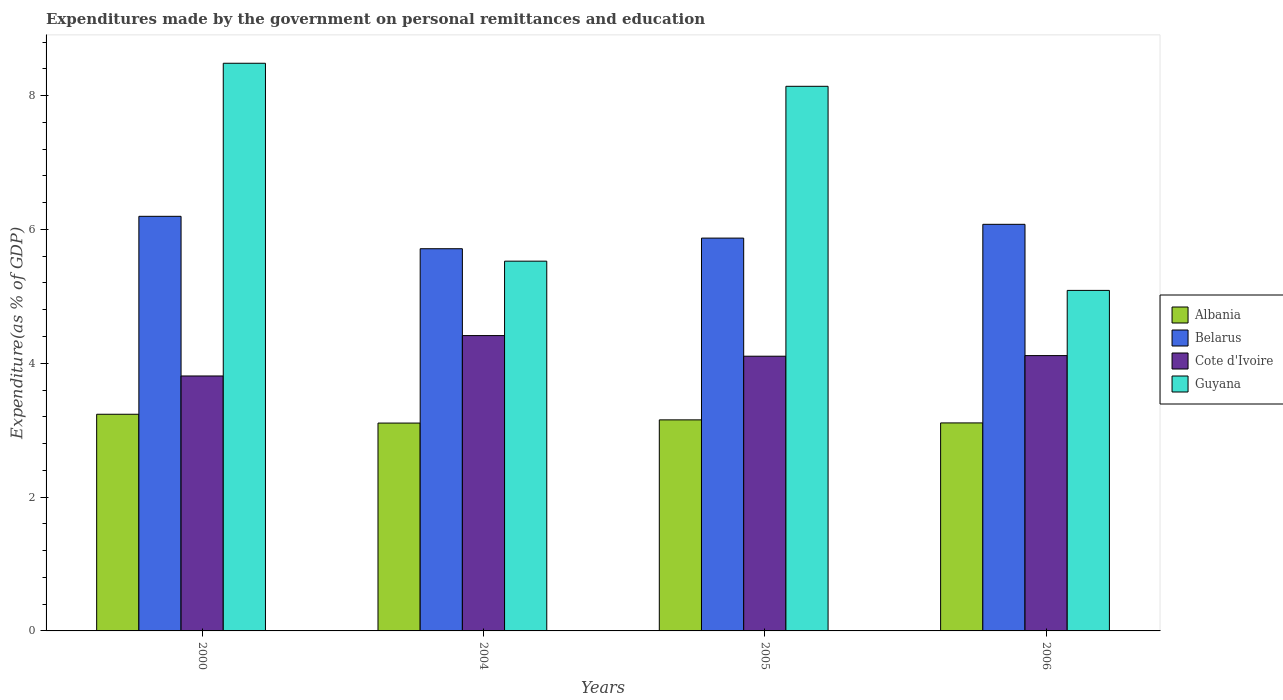How many different coloured bars are there?
Ensure brevity in your answer.  4. How many bars are there on the 3rd tick from the right?
Make the answer very short. 4. What is the label of the 2nd group of bars from the left?
Ensure brevity in your answer.  2004. What is the expenditures made by the government on personal remittances and education in Belarus in 2006?
Give a very brief answer. 6.08. Across all years, what is the maximum expenditures made by the government on personal remittances and education in Cote d'Ivoire?
Offer a very short reply. 4.41. Across all years, what is the minimum expenditures made by the government on personal remittances and education in Belarus?
Make the answer very short. 5.71. In which year was the expenditures made by the government on personal remittances and education in Guyana maximum?
Your answer should be very brief. 2000. What is the total expenditures made by the government on personal remittances and education in Belarus in the graph?
Your answer should be compact. 23.86. What is the difference between the expenditures made by the government on personal remittances and education in Cote d'Ivoire in 2000 and that in 2005?
Ensure brevity in your answer.  -0.3. What is the difference between the expenditures made by the government on personal remittances and education in Guyana in 2000 and the expenditures made by the government on personal remittances and education in Belarus in 2005?
Ensure brevity in your answer.  2.61. What is the average expenditures made by the government on personal remittances and education in Guyana per year?
Offer a terse response. 6.81. In the year 2004, what is the difference between the expenditures made by the government on personal remittances and education in Albania and expenditures made by the government on personal remittances and education in Cote d'Ivoire?
Offer a very short reply. -1.31. What is the ratio of the expenditures made by the government on personal remittances and education in Guyana in 2000 to that in 2005?
Give a very brief answer. 1.04. Is the difference between the expenditures made by the government on personal remittances and education in Albania in 2000 and 2006 greater than the difference between the expenditures made by the government on personal remittances and education in Cote d'Ivoire in 2000 and 2006?
Your answer should be compact. Yes. What is the difference between the highest and the second highest expenditures made by the government on personal remittances and education in Belarus?
Give a very brief answer. 0.12. What is the difference between the highest and the lowest expenditures made by the government on personal remittances and education in Albania?
Your answer should be very brief. 0.13. In how many years, is the expenditures made by the government on personal remittances and education in Belarus greater than the average expenditures made by the government on personal remittances and education in Belarus taken over all years?
Give a very brief answer. 2. Is the sum of the expenditures made by the government on personal remittances and education in Cote d'Ivoire in 2004 and 2006 greater than the maximum expenditures made by the government on personal remittances and education in Albania across all years?
Offer a very short reply. Yes. What does the 2nd bar from the left in 2006 represents?
Offer a terse response. Belarus. What does the 2nd bar from the right in 2006 represents?
Make the answer very short. Cote d'Ivoire. Are all the bars in the graph horizontal?
Make the answer very short. No. What is the difference between two consecutive major ticks on the Y-axis?
Ensure brevity in your answer.  2. Are the values on the major ticks of Y-axis written in scientific E-notation?
Provide a succinct answer. No. Does the graph contain grids?
Keep it short and to the point. No. How many legend labels are there?
Make the answer very short. 4. How are the legend labels stacked?
Provide a short and direct response. Vertical. What is the title of the graph?
Offer a terse response. Expenditures made by the government on personal remittances and education. What is the label or title of the Y-axis?
Offer a terse response. Expenditure(as % of GDP). What is the Expenditure(as % of GDP) of Albania in 2000?
Your answer should be compact. 3.24. What is the Expenditure(as % of GDP) of Belarus in 2000?
Offer a terse response. 6.2. What is the Expenditure(as % of GDP) of Cote d'Ivoire in 2000?
Ensure brevity in your answer.  3.81. What is the Expenditure(as % of GDP) of Guyana in 2000?
Offer a very short reply. 8.48. What is the Expenditure(as % of GDP) of Albania in 2004?
Your answer should be very brief. 3.11. What is the Expenditure(as % of GDP) of Belarus in 2004?
Ensure brevity in your answer.  5.71. What is the Expenditure(as % of GDP) in Cote d'Ivoire in 2004?
Provide a succinct answer. 4.41. What is the Expenditure(as % of GDP) of Guyana in 2004?
Your answer should be very brief. 5.53. What is the Expenditure(as % of GDP) of Albania in 2005?
Your response must be concise. 3.15. What is the Expenditure(as % of GDP) in Belarus in 2005?
Your answer should be compact. 5.87. What is the Expenditure(as % of GDP) in Cote d'Ivoire in 2005?
Provide a succinct answer. 4.11. What is the Expenditure(as % of GDP) in Guyana in 2005?
Your response must be concise. 8.14. What is the Expenditure(as % of GDP) in Albania in 2006?
Provide a short and direct response. 3.11. What is the Expenditure(as % of GDP) in Belarus in 2006?
Offer a terse response. 6.08. What is the Expenditure(as % of GDP) of Cote d'Ivoire in 2006?
Your answer should be compact. 4.11. What is the Expenditure(as % of GDP) of Guyana in 2006?
Make the answer very short. 5.09. Across all years, what is the maximum Expenditure(as % of GDP) of Albania?
Give a very brief answer. 3.24. Across all years, what is the maximum Expenditure(as % of GDP) in Belarus?
Make the answer very short. 6.2. Across all years, what is the maximum Expenditure(as % of GDP) in Cote d'Ivoire?
Offer a terse response. 4.41. Across all years, what is the maximum Expenditure(as % of GDP) of Guyana?
Offer a terse response. 8.48. Across all years, what is the minimum Expenditure(as % of GDP) in Albania?
Make the answer very short. 3.11. Across all years, what is the minimum Expenditure(as % of GDP) of Belarus?
Provide a succinct answer. 5.71. Across all years, what is the minimum Expenditure(as % of GDP) in Cote d'Ivoire?
Your answer should be compact. 3.81. Across all years, what is the minimum Expenditure(as % of GDP) in Guyana?
Keep it short and to the point. 5.09. What is the total Expenditure(as % of GDP) in Albania in the graph?
Offer a very short reply. 12.61. What is the total Expenditure(as % of GDP) in Belarus in the graph?
Provide a succinct answer. 23.86. What is the total Expenditure(as % of GDP) of Cote d'Ivoire in the graph?
Your response must be concise. 16.44. What is the total Expenditure(as % of GDP) of Guyana in the graph?
Your answer should be compact. 27.24. What is the difference between the Expenditure(as % of GDP) of Albania in 2000 and that in 2004?
Offer a very short reply. 0.13. What is the difference between the Expenditure(as % of GDP) of Belarus in 2000 and that in 2004?
Make the answer very short. 0.48. What is the difference between the Expenditure(as % of GDP) of Cote d'Ivoire in 2000 and that in 2004?
Provide a succinct answer. -0.6. What is the difference between the Expenditure(as % of GDP) in Guyana in 2000 and that in 2004?
Offer a very short reply. 2.96. What is the difference between the Expenditure(as % of GDP) of Albania in 2000 and that in 2005?
Your answer should be compact. 0.08. What is the difference between the Expenditure(as % of GDP) of Belarus in 2000 and that in 2005?
Ensure brevity in your answer.  0.33. What is the difference between the Expenditure(as % of GDP) in Cote d'Ivoire in 2000 and that in 2005?
Provide a succinct answer. -0.3. What is the difference between the Expenditure(as % of GDP) in Guyana in 2000 and that in 2005?
Your answer should be very brief. 0.34. What is the difference between the Expenditure(as % of GDP) of Albania in 2000 and that in 2006?
Make the answer very short. 0.13. What is the difference between the Expenditure(as % of GDP) in Belarus in 2000 and that in 2006?
Keep it short and to the point. 0.12. What is the difference between the Expenditure(as % of GDP) in Cote d'Ivoire in 2000 and that in 2006?
Provide a short and direct response. -0.3. What is the difference between the Expenditure(as % of GDP) of Guyana in 2000 and that in 2006?
Keep it short and to the point. 3.39. What is the difference between the Expenditure(as % of GDP) in Albania in 2004 and that in 2005?
Keep it short and to the point. -0.05. What is the difference between the Expenditure(as % of GDP) in Belarus in 2004 and that in 2005?
Provide a short and direct response. -0.16. What is the difference between the Expenditure(as % of GDP) of Cote d'Ivoire in 2004 and that in 2005?
Offer a terse response. 0.31. What is the difference between the Expenditure(as % of GDP) in Guyana in 2004 and that in 2005?
Make the answer very short. -2.61. What is the difference between the Expenditure(as % of GDP) of Albania in 2004 and that in 2006?
Make the answer very short. -0. What is the difference between the Expenditure(as % of GDP) of Belarus in 2004 and that in 2006?
Provide a succinct answer. -0.36. What is the difference between the Expenditure(as % of GDP) of Cote d'Ivoire in 2004 and that in 2006?
Offer a terse response. 0.3. What is the difference between the Expenditure(as % of GDP) in Guyana in 2004 and that in 2006?
Give a very brief answer. 0.44. What is the difference between the Expenditure(as % of GDP) in Albania in 2005 and that in 2006?
Provide a succinct answer. 0.05. What is the difference between the Expenditure(as % of GDP) of Belarus in 2005 and that in 2006?
Your answer should be very brief. -0.21. What is the difference between the Expenditure(as % of GDP) of Cote d'Ivoire in 2005 and that in 2006?
Your answer should be compact. -0.01. What is the difference between the Expenditure(as % of GDP) of Guyana in 2005 and that in 2006?
Give a very brief answer. 3.05. What is the difference between the Expenditure(as % of GDP) of Albania in 2000 and the Expenditure(as % of GDP) of Belarus in 2004?
Ensure brevity in your answer.  -2.47. What is the difference between the Expenditure(as % of GDP) of Albania in 2000 and the Expenditure(as % of GDP) of Cote d'Ivoire in 2004?
Ensure brevity in your answer.  -1.18. What is the difference between the Expenditure(as % of GDP) of Albania in 2000 and the Expenditure(as % of GDP) of Guyana in 2004?
Offer a terse response. -2.29. What is the difference between the Expenditure(as % of GDP) in Belarus in 2000 and the Expenditure(as % of GDP) in Cote d'Ivoire in 2004?
Your answer should be compact. 1.78. What is the difference between the Expenditure(as % of GDP) in Belarus in 2000 and the Expenditure(as % of GDP) in Guyana in 2004?
Your answer should be compact. 0.67. What is the difference between the Expenditure(as % of GDP) in Cote d'Ivoire in 2000 and the Expenditure(as % of GDP) in Guyana in 2004?
Provide a succinct answer. -1.72. What is the difference between the Expenditure(as % of GDP) in Albania in 2000 and the Expenditure(as % of GDP) in Belarus in 2005?
Provide a succinct answer. -2.63. What is the difference between the Expenditure(as % of GDP) of Albania in 2000 and the Expenditure(as % of GDP) of Cote d'Ivoire in 2005?
Ensure brevity in your answer.  -0.87. What is the difference between the Expenditure(as % of GDP) in Albania in 2000 and the Expenditure(as % of GDP) in Guyana in 2005?
Offer a very short reply. -4.9. What is the difference between the Expenditure(as % of GDP) of Belarus in 2000 and the Expenditure(as % of GDP) of Cote d'Ivoire in 2005?
Your response must be concise. 2.09. What is the difference between the Expenditure(as % of GDP) of Belarus in 2000 and the Expenditure(as % of GDP) of Guyana in 2005?
Make the answer very short. -1.94. What is the difference between the Expenditure(as % of GDP) in Cote d'Ivoire in 2000 and the Expenditure(as % of GDP) in Guyana in 2005?
Offer a terse response. -4.33. What is the difference between the Expenditure(as % of GDP) of Albania in 2000 and the Expenditure(as % of GDP) of Belarus in 2006?
Your answer should be compact. -2.84. What is the difference between the Expenditure(as % of GDP) of Albania in 2000 and the Expenditure(as % of GDP) of Cote d'Ivoire in 2006?
Provide a succinct answer. -0.88. What is the difference between the Expenditure(as % of GDP) in Albania in 2000 and the Expenditure(as % of GDP) in Guyana in 2006?
Your answer should be compact. -1.85. What is the difference between the Expenditure(as % of GDP) in Belarus in 2000 and the Expenditure(as % of GDP) in Cote d'Ivoire in 2006?
Your response must be concise. 2.08. What is the difference between the Expenditure(as % of GDP) in Belarus in 2000 and the Expenditure(as % of GDP) in Guyana in 2006?
Provide a succinct answer. 1.11. What is the difference between the Expenditure(as % of GDP) in Cote d'Ivoire in 2000 and the Expenditure(as % of GDP) in Guyana in 2006?
Make the answer very short. -1.28. What is the difference between the Expenditure(as % of GDP) in Albania in 2004 and the Expenditure(as % of GDP) in Belarus in 2005?
Give a very brief answer. -2.76. What is the difference between the Expenditure(as % of GDP) in Albania in 2004 and the Expenditure(as % of GDP) in Cote d'Ivoire in 2005?
Offer a terse response. -1. What is the difference between the Expenditure(as % of GDP) in Albania in 2004 and the Expenditure(as % of GDP) in Guyana in 2005?
Keep it short and to the point. -5.03. What is the difference between the Expenditure(as % of GDP) in Belarus in 2004 and the Expenditure(as % of GDP) in Cote d'Ivoire in 2005?
Make the answer very short. 1.61. What is the difference between the Expenditure(as % of GDP) of Belarus in 2004 and the Expenditure(as % of GDP) of Guyana in 2005?
Provide a short and direct response. -2.43. What is the difference between the Expenditure(as % of GDP) of Cote d'Ivoire in 2004 and the Expenditure(as % of GDP) of Guyana in 2005?
Your answer should be compact. -3.73. What is the difference between the Expenditure(as % of GDP) of Albania in 2004 and the Expenditure(as % of GDP) of Belarus in 2006?
Offer a very short reply. -2.97. What is the difference between the Expenditure(as % of GDP) in Albania in 2004 and the Expenditure(as % of GDP) in Cote d'Ivoire in 2006?
Make the answer very short. -1.01. What is the difference between the Expenditure(as % of GDP) of Albania in 2004 and the Expenditure(as % of GDP) of Guyana in 2006?
Keep it short and to the point. -1.98. What is the difference between the Expenditure(as % of GDP) in Belarus in 2004 and the Expenditure(as % of GDP) in Cote d'Ivoire in 2006?
Your answer should be compact. 1.6. What is the difference between the Expenditure(as % of GDP) in Belarus in 2004 and the Expenditure(as % of GDP) in Guyana in 2006?
Provide a short and direct response. 0.62. What is the difference between the Expenditure(as % of GDP) in Cote d'Ivoire in 2004 and the Expenditure(as % of GDP) in Guyana in 2006?
Ensure brevity in your answer.  -0.68. What is the difference between the Expenditure(as % of GDP) in Albania in 2005 and the Expenditure(as % of GDP) in Belarus in 2006?
Make the answer very short. -2.92. What is the difference between the Expenditure(as % of GDP) of Albania in 2005 and the Expenditure(as % of GDP) of Cote d'Ivoire in 2006?
Offer a very short reply. -0.96. What is the difference between the Expenditure(as % of GDP) of Albania in 2005 and the Expenditure(as % of GDP) of Guyana in 2006?
Provide a short and direct response. -1.93. What is the difference between the Expenditure(as % of GDP) in Belarus in 2005 and the Expenditure(as % of GDP) in Cote d'Ivoire in 2006?
Your answer should be compact. 1.76. What is the difference between the Expenditure(as % of GDP) in Belarus in 2005 and the Expenditure(as % of GDP) in Guyana in 2006?
Keep it short and to the point. 0.78. What is the difference between the Expenditure(as % of GDP) of Cote d'Ivoire in 2005 and the Expenditure(as % of GDP) of Guyana in 2006?
Make the answer very short. -0.98. What is the average Expenditure(as % of GDP) of Albania per year?
Your answer should be very brief. 3.15. What is the average Expenditure(as % of GDP) in Belarus per year?
Offer a terse response. 5.96. What is the average Expenditure(as % of GDP) of Cote d'Ivoire per year?
Provide a short and direct response. 4.11. What is the average Expenditure(as % of GDP) in Guyana per year?
Make the answer very short. 6.81. In the year 2000, what is the difference between the Expenditure(as % of GDP) in Albania and Expenditure(as % of GDP) in Belarus?
Your response must be concise. -2.96. In the year 2000, what is the difference between the Expenditure(as % of GDP) of Albania and Expenditure(as % of GDP) of Cote d'Ivoire?
Give a very brief answer. -0.57. In the year 2000, what is the difference between the Expenditure(as % of GDP) of Albania and Expenditure(as % of GDP) of Guyana?
Keep it short and to the point. -5.25. In the year 2000, what is the difference between the Expenditure(as % of GDP) in Belarus and Expenditure(as % of GDP) in Cote d'Ivoire?
Keep it short and to the point. 2.39. In the year 2000, what is the difference between the Expenditure(as % of GDP) in Belarus and Expenditure(as % of GDP) in Guyana?
Ensure brevity in your answer.  -2.29. In the year 2000, what is the difference between the Expenditure(as % of GDP) in Cote d'Ivoire and Expenditure(as % of GDP) in Guyana?
Keep it short and to the point. -4.67. In the year 2004, what is the difference between the Expenditure(as % of GDP) in Albania and Expenditure(as % of GDP) in Belarus?
Ensure brevity in your answer.  -2.61. In the year 2004, what is the difference between the Expenditure(as % of GDP) of Albania and Expenditure(as % of GDP) of Cote d'Ivoire?
Offer a very short reply. -1.31. In the year 2004, what is the difference between the Expenditure(as % of GDP) of Albania and Expenditure(as % of GDP) of Guyana?
Your answer should be very brief. -2.42. In the year 2004, what is the difference between the Expenditure(as % of GDP) of Belarus and Expenditure(as % of GDP) of Cote d'Ivoire?
Offer a terse response. 1.3. In the year 2004, what is the difference between the Expenditure(as % of GDP) of Belarus and Expenditure(as % of GDP) of Guyana?
Ensure brevity in your answer.  0.19. In the year 2004, what is the difference between the Expenditure(as % of GDP) of Cote d'Ivoire and Expenditure(as % of GDP) of Guyana?
Make the answer very short. -1.11. In the year 2005, what is the difference between the Expenditure(as % of GDP) in Albania and Expenditure(as % of GDP) in Belarus?
Offer a terse response. -2.72. In the year 2005, what is the difference between the Expenditure(as % of GDP) of Albania and Expenditure(as % of GDP) of Cote d'Ivoire?
Your answer should be very brief. -0.95. In the year 2005, what is the difference between the Expenditure(as % of GDP) of Albania and Expenditure(as % of GDP) of Guyana?
Provide a short and direct response. -4.99. In the year 2005, what is the difference between the Expenditure(as % of GDP) of Belarus and Expenditure(as % of GDP) of Cote d'Ivoire?
Offer a very short reply. 1.77. In the year 2005, what is the difference between the Expenditure(as % of GDP) of Belarus and Expenditure(as % of GDP) of Guyana?
Your answer should be very brief. -2.27. In the year 2005, what is the difference between the Expenditure(as % of GDP) in Cote d'Ivoire and Expenditure(as % of GDP) in Guyana?
Your answer should be very brief. -4.03. In the year 2006, what is the difference between the Expenditure(as % of GDP) of Albania and Expenditure(as % of GDP) of Belarus?
Your response must be concise. -2.97. In the year 2006, what is the difference between the Expenditure(as % of GDP) of Albania and Expenditure(as % of GDP) of Cote d'Ivoire?
Your response must be concise. -1.01. In the year 2006, what is the difference between the Expenditure(as % of GDP) in Albania and Expenditure(as % of GDP) in Guyana?
Keep it short and to the point. -1.98. In the year 2006, what is the difference between the Expenditure(as % of GDP) of Belarus and Expenditure(as % of GDP) of Cote d'Ivoire?
Keep it short and to the point. 1.96. In the year 2006, what is the difference between the Expenditure(as % of GDP) of Cote d'Ivoire and Expenditure(as % of GDP) of Guyana?
Make the answer very short. -0.97. What is the ratio of the Expenditure(as % of GDP) of Albania in 2000 to that in 2004?
Offer a very short reply. 1.04. What is the ratio of the Expenditure(as % of GDP) in Belarus in 2000 to that in 2004?
Keep it short and to the point. 1.08. What is the ratio of the Expenditure(as % of GDP) of Cote d'Ivoire in 2000 to that in 2004?
Keep it short and to the point. 0.86. What is the ratio of the Expenditure(as % of GDP) in Guyana in 2000 to that in 2004?
Make the answer very short. 1.54. What is the ratio of the Expenditure(as % of GDP) in Albania in 2000 to that in 2005?
Your answer should be compact. 1.03. What is the ratio of the Expenditure(as % of GDP) in Belarus in 2000 to that in 2005?
Your response must be concise. 1.06. What is the ratio of the Expenditure(as % of GDP) of Cote d'Ivoire in 2000 to that in 2005?
Keep it short and to the point. 0.93. What is the ratio of the Expenditure(as % of GDP) of Guyana in 2000 to that in 2005?
Offer a very short reply. 1.04. What is the ratio of the Expenditure(as % of GDP) of Albania in 2000 to that in 2006?
Give a very brief answer. 1.04. What is the ratio of the Expenditure(as % of GDP) of Belarus in 2000 to that in 2006?
Ensure brevity in your answer.  1.02. What is the ratio of the Expenditure(as % of GDP) in Cote d'Ivoire in 2000 to that in 2006?
Offer a very short reply. 0.93. What is the ratio of the Expenditure(as % of GDP) in Guyana in 2000 to that in 2006?
Make the answer very short. 1.67. What is the ratio of the Expenditure(as % of GDP) of Cote d'Ivoire in 2004 to that in 2005?
Offer a terse response. 1.08. What is the ratio of the Expenditure(as % of GDP) of Guyana in 2004 to that in 2005?
Your answer should be very brief. 0.68. What is the ratio of the Expenditure(as % of GDP) of Belarus in 2004 to that in 2006?
Provide a short and direct response. 0.94. What is the ratio of the Expenditure(as % of GDP) in Cote d'Ivoire in 2004 to that in 2006?
Offer a very short reply. 1.07. What is the ratio of the Expenditure(as % of GDP) of Guyana in 2004 to that in 2006?
Your response must be concise. 1.09. What is the ratio of the Expenditure(as % of GDP) of Albania in 2005 to that in 2006?
Offer a very short reply. 1.01. What is the ratio of the Expenditure(as % of GDP) of Belarus in 2005 to that in 2006?
Your answer should be very brief. 0.97. What is the ratio of the Expenditure(as % of GDP) in Guyana in 2005 to that in 2006?
Offer a terse response. 1.6. What is the difference between the highest and the second highest Expenditure(as % of GDP) of Albania?
Provide a succinct answer. 0.08. What is the difference between the highest and the second highest Expenditure(as % of GDP) of Belarus?
Ensure brevity in your answer.  0.12. What is the difference between the highest and the second highest Expenditure(as % of GDP) of Cote d'Ivoire?
Provide a short and direct response. 0.3. What is the difference between the highest and the second highest Expenditure(as % of GDP) in Guyana?
Provide a succinct answer. 0.34. What is the difference between the highest and the lowest Expenditure(as % of GDP) of Albania?
Your answer should be compact. 0.13. What is the difference between the highest and the lowest Expenditure(as % of GDP) in Belarus?
Offer a very short reply. 0.48. What is the difference between the highest and the lowest Expenditure(as % of GDP) of Cote d'Ivoire?
Provide a short and direct response. 0.6. What is the difference between the highest and the lowest Expenditure(as % of GDP) in Guyana?
Provide a short and direct response. 3.39. 